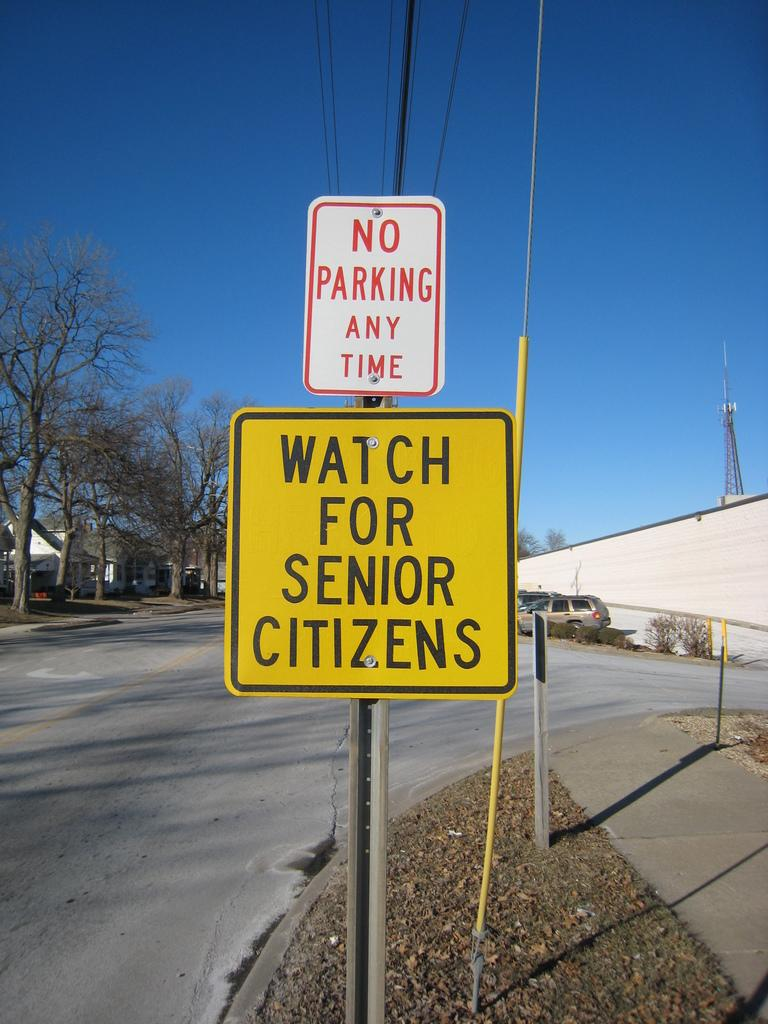<image>
Describe the image concisely. a No Parking Any Time sign over a Watch for Senior Citizens sign 